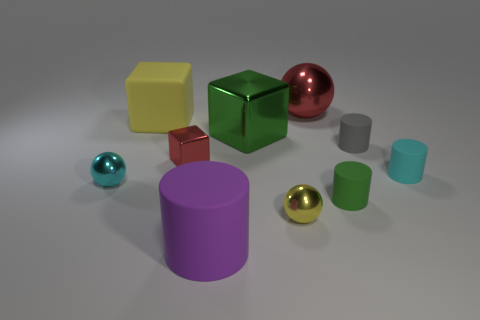Subtract all red metallic blocks. How many blocks are left? 2 Subtract 1 cubes. How many cubes are left? 2 Subtract all purple cylinders. How many cylinders are left? 3 Subtract all purple balls. Subtract all gray cylinders. How many balls are left? 3 Subtract all spheres. How many objects are left? 7 Subtract 0 red cylinders. How many objects are left? 10 Subtract all small gray rubber things. Subtract all tiny cyan shiny spheres. How many objects are left? 8 Add 2 purple matte objects. How many purple matte objects are left? 3 Add 2 gray rubber things. How many gray rubber things exist? 3 